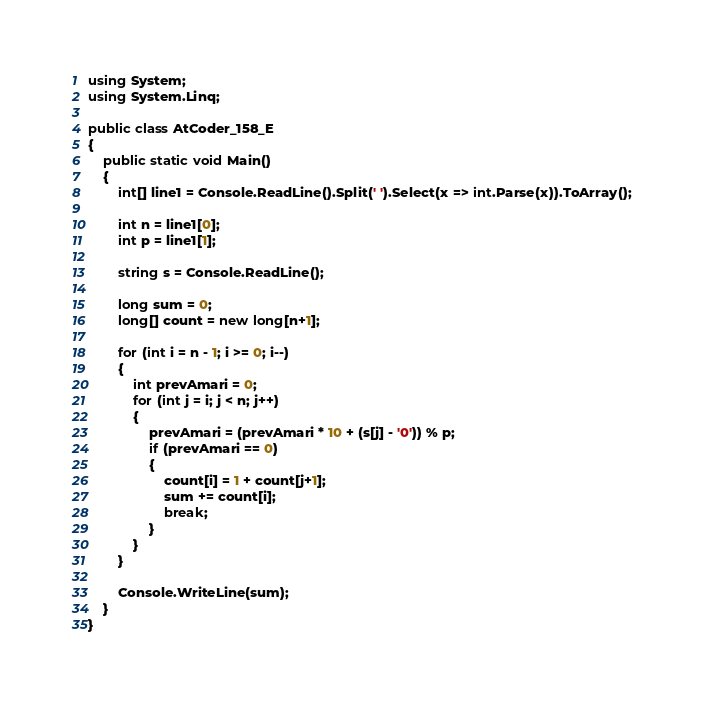<code> <loc_0><loc_0><loc_500><loc_500><_C#_>using System;
using System.Linq;

public class AtCoder_158_E
{
    public static void Main()
    {
        int[] line1 = Console.ReadLine().Split(' ').Select(x => int.Parse(x)).ToArray();

        int n = line1[0];
        int p = line1[1];

        string s = Console.ReadLine();

        long sum = 0;
        long[] count = new long[n+1];

        for (int i = n - 1; i >= 0; i--)
        {
            int prevAmari = 0;
            for (int j = i; j < n; j++)
            {
                prevAmari = (prevAmari * 10 + (s[j] - '0')) % p;
                if (prevAmari == 0)
                {
                    count[i] = 1 + count[j+1];
                    sum += count[i];
                    break;
                }
            }
        }

        Console.WriteLine(sum);
    }
}
</code> 